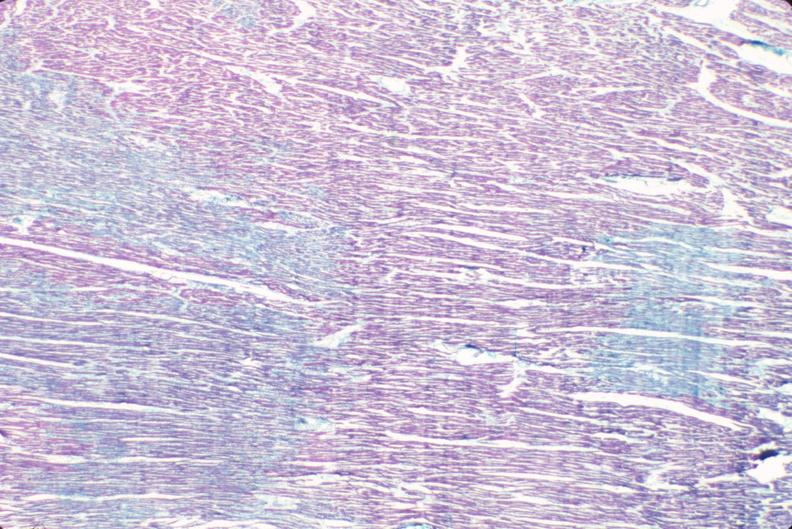where is this from?
Answer the question using a single word or phrase. Heart 